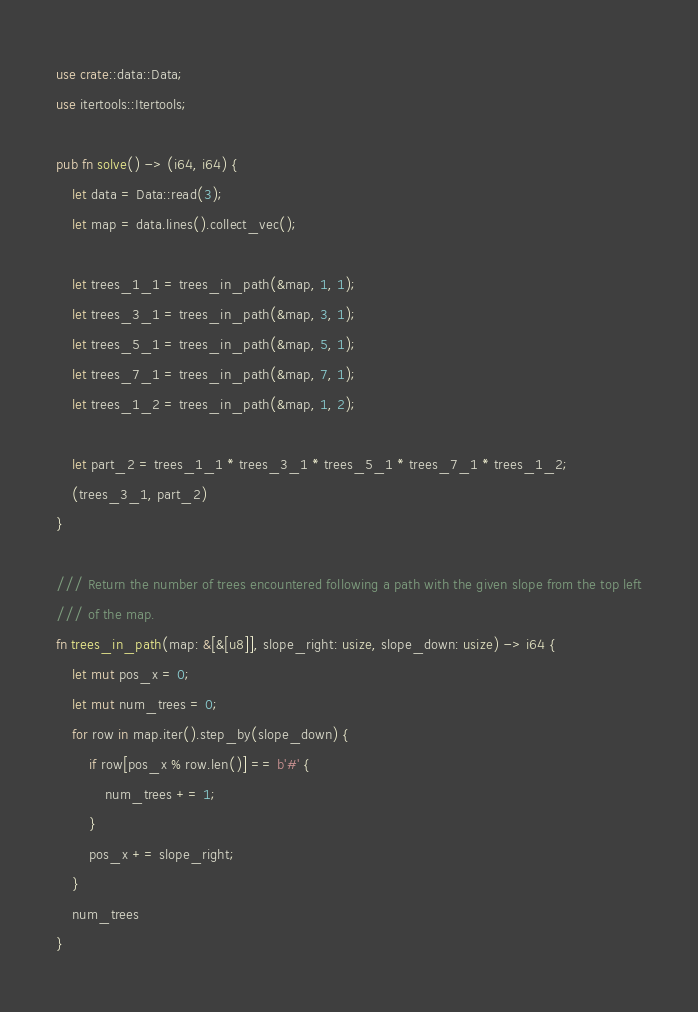Convert code to text. <code><loc_0><loc_0><loc_500><loc_500><_Rust_>use crate::data::Data;
use itertools::Itertools;

pub fn solve() -> (i64, i64) {
    let data = Data::read(3);
    let map = data.lines().collect_vec();

    let trees_1_1 = trees_in_path(&map, 1, 1);
    let trees_3_1 = trees_in_path(&map, 3, 1);
    let trees_5_1 = trees_in_path(&map, 5, 1);
    let trees_7_1 = trees_in_path(&map, 7, 1);
    let trees_1_2 = trees_in_path(&map, 1, 2);

    let part_2 = trees_1_1 * trees_3_1 * trees_5_1 * trees_7_1 * trees_1_2;
    (trees_3_1, part_2)
}

/// Return the number of trees encountered following a path with the given slope from the top left
/// of the map.
fn trees_in_path(map: &[&[u8]], slope_right: usize, slope_down: usize) -> i64 {
    let mut pos_x = 0;
    let mut num_trees = 0;
    for row in map.iter().step_by(slope_down) {
        if row[pos_x % row.len()] == b'#' {
            num_trees += 1;
        }
        pos_x += slope_right;
    }
    num_trees
}
</code> 